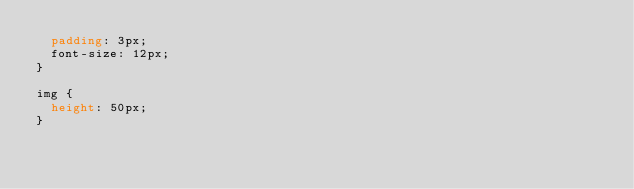Convert code to text. <code><loc_0><loc_0><loc_500><loc_500><_CSS_>  padding: 3px;
  font-size: 12px;
}

img {
  height: 50px;
}
</code> 